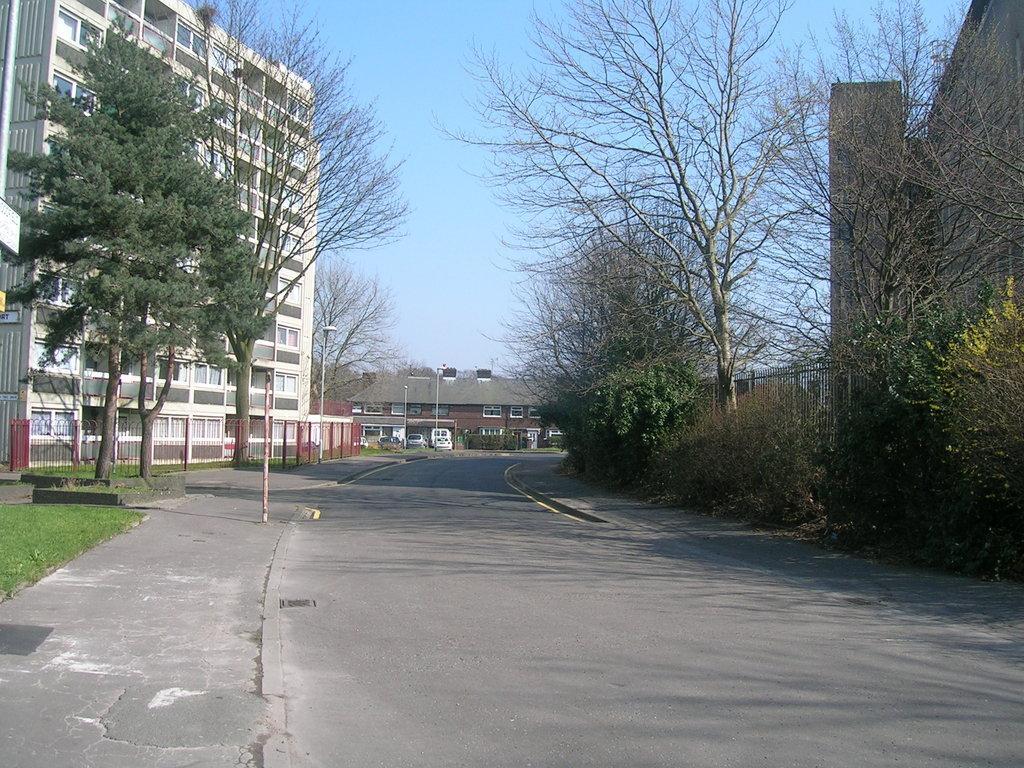Describe this image in one or two sentences. This picture consist of outside view of a city and in the middle I can see a road , on the left side I can see a building , in front of the building I can see red color fence and trees. in the middle I can see a building and the sky and street light pole and on the right side I can see the wall and trees. 